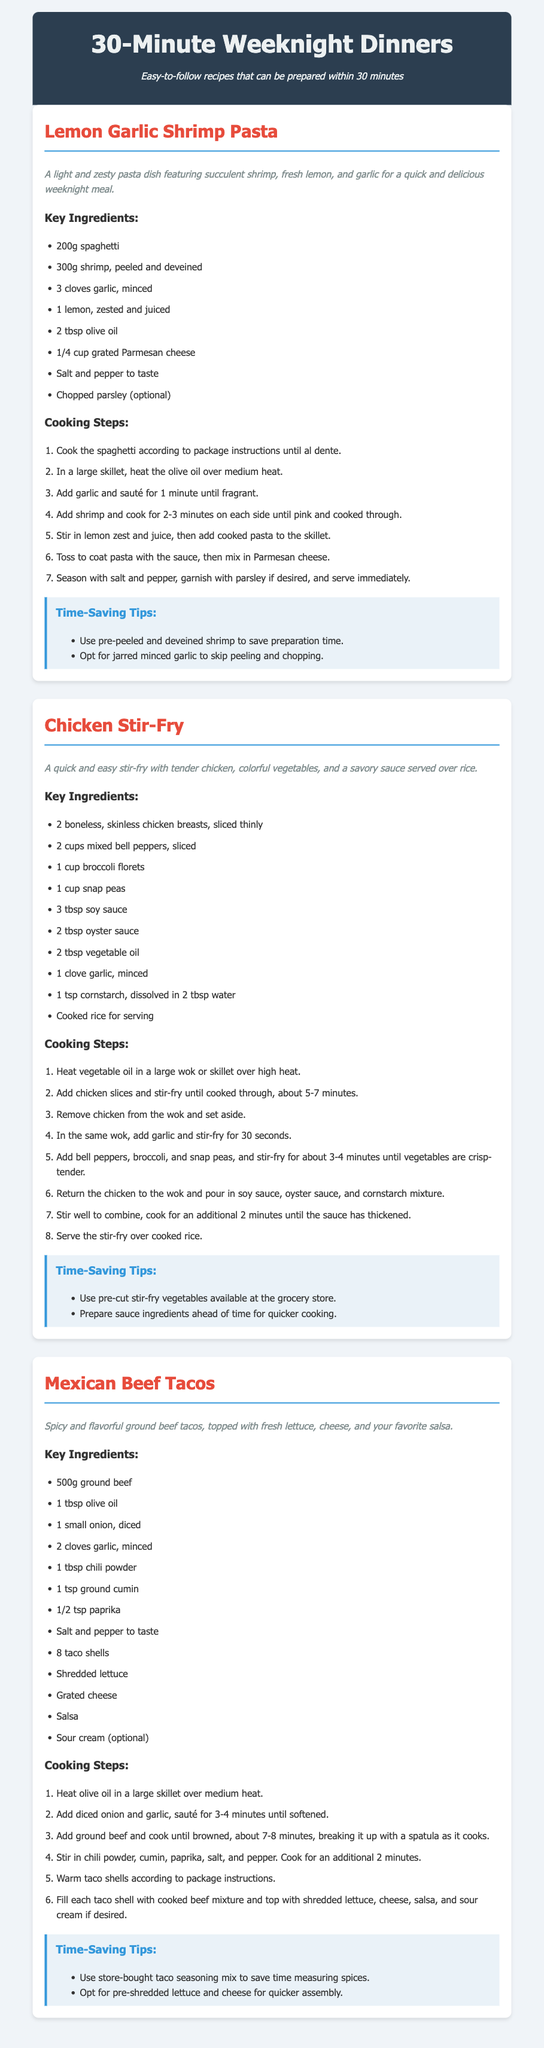What is the title of the first recipe? The first recipe is titled "Lemon Garlic Shrimp Pasta."
Answer: Lemon Garlic Shrimp Pasta How many key ingredients are listed for the Chicken Stir-Fry? The Chicken Stir-Fry recipe lists 10 key ingredients.
Answer: 10 Which type of cooking method is used for the Mexican Beef Tacos? The document specifies a skillet for cooking, indicating sautéing is used for the tacos.
Answer: Skillet What is the cooking time for the shrimp in the first recipe? The shrimp should be cooked for 2-3 minutes on each side, according to the document.
Answer: 2-3 minutes What are the time-saving tips mentioned for the Lemon Garlic Shrimp Pasta? The tips include using pre-peeled shrimp and jarred minced garlic to save time.
Answer: Pre-peeled shrimp, jarred minced garlic What is the main protein used in the Chicken Stir-Fry? The main protein featured in this dish is chicken.
Answer: Chicken What is one optional ingredient for the Lemon Garlic Shrimp Pasta? The recipe suggests chopped parsley as an optional ingredient.
Answer: Chopped parsley How many taco shells are needed for the Mexican Beef Tacos? The recipe indicates that 8 taco shells are required.
Answer: 8 